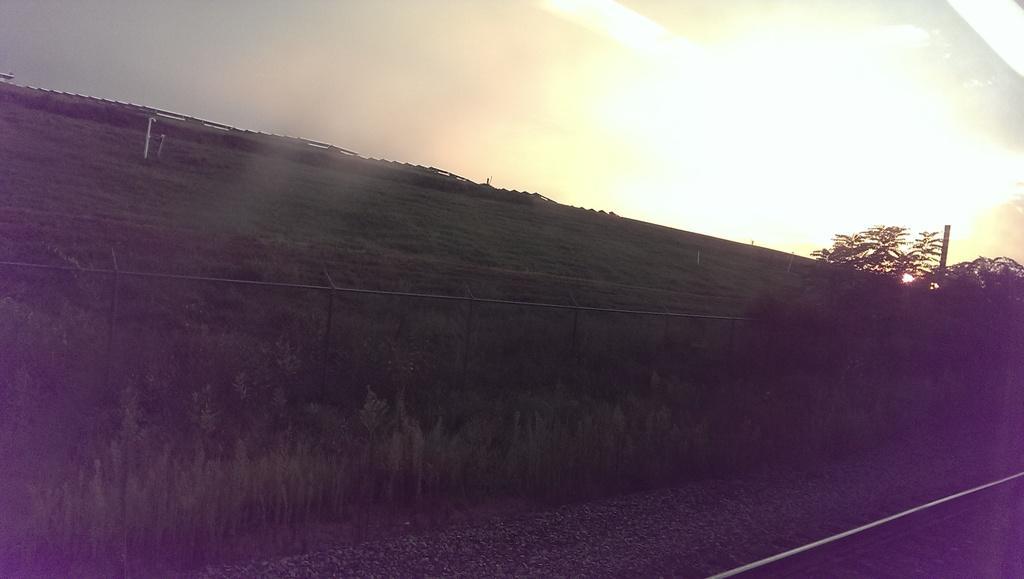Describe this image in one or two sentences. This picture is clicked outside. In the foreground we can see the gravel, railway track, plants, net, metal rods. In the background we can see the sky and the trees and some other objects. 